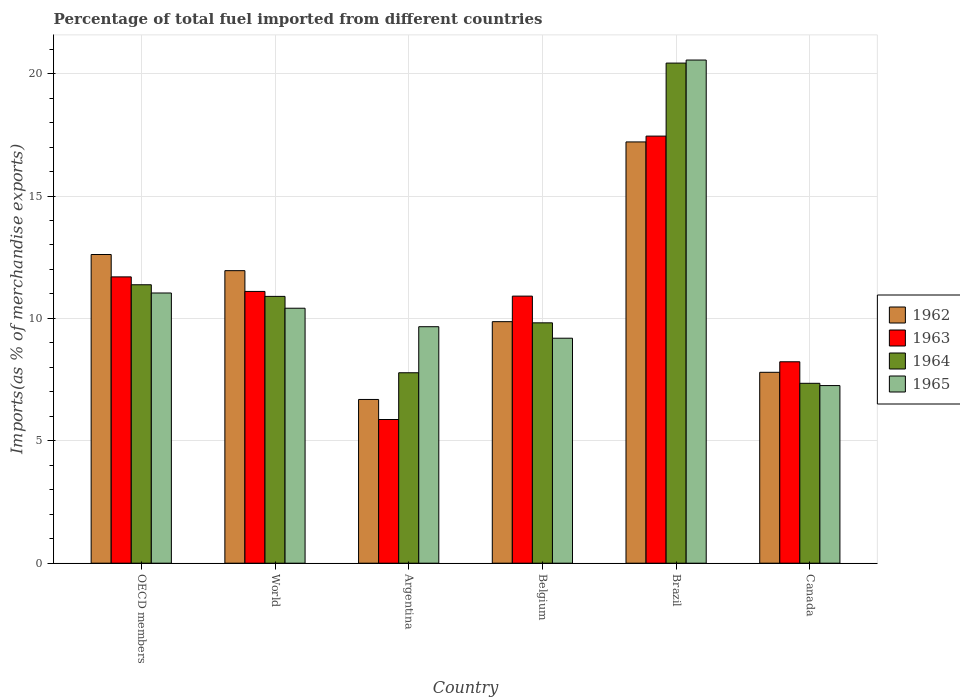How many different coloured bars are there?
Provide a short and direct response. 4. How many groups of bars are there?
Provide a succinct answer. 6. Are the number of bars on each tick of the X-axis equal?
Your response must be concise. Yes. How many bars are there on the 1st tick from the left?
Give a very brief answer. 4. What is the label of the 3rd group of bars from the left?
Keep it short and to the point. Argentina. In how many cases, is the number of bars for a given country not equal to the number of legend labels?
Provide a succinct answer. 0. What is the percentage of imports to different countries in 1962 in Argentina?
Provide a short and direct response. 6.69. Across all countries, what is the maximum percentage of imports to different countries in 1962?
Ensure brevity in your answer.  17.21. Across all countries, what is the minimum percentage of imports to different countries in 1965?
Your response must be concise. 7.26. In which country was the percentage of imports to different countries in 1964 maximum?
Keep it short and to the point. Brazil. What is the total percentage of imports to different countries in 1963 in the graph?
Your answer should be very brief. 65.25. What is the difference between the percentage of imports to different countries in 1963 in Argentina and that in Belgium?
Make the answer very short. -5.04. What is the difference between the percentage of imports to different countries in 1962 in Brazil and the percentage of imports to different countries in 1965 in Canada?
Provide a succinct answer. 9.95. What is the average percentage of imports to different countries in 1965 per country?
Provide a succinct answer. 11.35. What is the difference between the percentage of imports to different countries of/in 1965 and percentage of imports to different countries of/in 1962 in Argentina?
Keep it short and to the point. 2.97. What is the ratio of the percentage of imports to different countries in 1962 in Belgium to that in World?
Offer a terse response. 0.83. Is the percentage of imports to different countries in 1965 in Argentina less than that in World?
Keep it short and to the point. Yes. Is the difference between the percentage of imports to different countries in 1965 in Belgium and Canada greater than the difference between the percentage of imports to different countries in 1962 in Belgium and Canada?
Provide a succinct answer. No. What is the difference between the highest and the second highest percentage of imports to different countries in 1964?
Your answer should be very brief. -0.48. What is the difference between the highest and the lowest percentage of imports to different countries in 1965?
Offer a terse response. 13.3. Is the sum of the percentage of imports to different countries in 1965 in Belgium and Canada greater than the maximum percentage of imports to different countries in 1962 across all countries?
Your answer should be compact. No. Is it the case that in every country, the sum of the percentage of imports to different countries in 1965 and percentage of imports to different countries in 1963 is greater than the sum of percentage of imports to different countries in 1962 and percentage of imports to different countries in 1964?
Your answer should be very brief. No. What does the 3rd bar from the left in Canada represents?
Keep it short and to the point. 1964. What does the 3rd bar from the right in Brazil represents?
Keep it short and to the point. 1963. Is it the case that in every country, the sum of the percentage of imports to different countries in 1962 and percentage of imports to different countries in 1963 is greater than the percentage of imports to different countries in 1965?
Your answer should be compact. Yes. How many bars are there?
Keep it short and to the point. 24. How many countries are there in the graph?
Ensure brevity in your answer.  6. Does the graph contain any zero values?
Your answer should be very brief. No. Does the graph contain grids?
Provide a succinct answer. Yes. Where does the legend appear in the graph?
Provide a short and direct response. Center right. What is the title of the graph?
Give a very brief answer. Percentage of total fuel imported from different countries. Does "1965" appear as one of the legend labels in the graph?
Offer a very short reply. Yes. What is the label or title of the Y-axis?
Give a very brief answer. Imports(as % of merchandise exports). What is the Imports(as % of merchandise exports) in 1962 in OECD members?
Provide a succinct answer. 12.61. What is the Imports(as % of merchandise exports) in 1963 in OECD members?
Keep it short and to the point. 11.7. What is the Imports(as % of merchandise exports) in 1964 in OECD members?
Keep it short and to the point. 11.37. What is the Imports(as % of merchandise exports) of 1965 in OECD members?
Your answer should be very brief. 11.04. What is the Imports(as % of merchandise exports) in 1962 in World?
Offer a very short reply. 11.95. What is the Imports(as % of merchandise exports) in 1963 in World?
Give a very brief answer. 11.1. What is the Imports(as % of merchandise exports) of 1964 in World?
Your response must be concise. 10.9. What is the Imports(as % of merchandise exports) of 1965 in World?
Your response must be concise. 10.42. What is the Imports(as % of merchandise exports) in 1962 in Argentina?
Make the answer very short. 6.69. What is the Imports(as % of merchandise exports) of 1963 in Argentina?
Offer a terse response. 5.87. What is the Imports(as % of merchandise exports) of 1964 in Argentina?
Make the answer very short. 7.78. What is the Imports(as % of merchandise exports) of 1965 in Argentina?
Provide a short and direct response. 9.66. What is the Imports(as % of merchandise exports) in 1962 in Belgium?
Your answer should be very brief. 9.87. What is the Imports(as % of merchandise exports) of 1963 in Belgium?
Give a very brief answer. 10.91. What is the Imports(as % of merchandise exports) in 1964 in Belgium?
Keep it short and to the point. 9.82. What is the Imports(as % of merchandise exports) in 1965 in Belgium?
Ensure brevity in your answer.  9.19. What is the Imports(as % of merchandise exports) of 1962 in Brazil?
Make the answer very short. 17.21. What is the Imports(as % of merchandise exports) of 1963 in Brazil?
Keep it short and to the point. 17.45. What is the Imports(as % of merchandise exports) in 1964 in Brazil?
Make the answer very short. 20.43. What is the Imports(as % of merchandise exports) in 1965 in Brazil?
Provide a succinct answer. 20.55. What is the Imports(as % of merchandise exports) of 1962 in Canada?
Ensure brevity in your answer.  7.8. What is the Imports(as % of merchandise exports) in 1963 in Canada?
Provide a short and direct response. 8.23. What is the Imports(as % of merchandise exports) in 1964 in Canada?
Provide a succinct answer. 7.35. What is the Imports(as % of merchandise exports) in 1965 in Canada?
Ensure brevity in your answer.  7.26. Across all countries, what is the maximum Imports(as % of merchandise exports) in 1962?
Give a very brief answer. 17.21. Across all countries, what is the maximum Imports(as % of merchandise exports) in 1963?
Your response must be concise. 17.45. Across all countries, what is the maximum Imports(as % of merchandise exports) in 1964?
Provide a short and direct response. 20.43. Across all countries, what is the maximum Imports(as % of merchandise exports) of 1965?
Your response must be concise. 20.55. Across all countries, what is the minimum Imports(as % of merchandise exports) of 1962?
Your answer should be very brief. 6.69. Across all countries, what is the minimum Imports(as % of merchandise exports) of 1963?
Your answer should be very brief. 5.87. Across all countries, what is the minimum Imports(as % of merchandise exports) in 1964?
Keep it short and to the point. 7.35. Across all countries, what is the minimum Imports(as % of merchandise exports) of 1965?
Offer a terse response. 7.26. What is the total Imports(as % of merchandise exports) in 1962 in the graph?
Provide a short and direct response. 66.12. What is the total Imports(as % of merchandise exports) of 1963 in the graph?
Offer a terse response. 65.25. What is the total Imports(as % of merchandise exports) of 1964 in the graph?
Ensure brevity in your answer.  67.65. What is the total Imports(as % of merchandise exports) in 1965 in the graph?
Your answer should be compact. 68.12. What is the difference between the Imports(as % of merchandise exports) of 1962 in OECD members and that in World?
Offer a terse response. 0.66. What is the difference between the Imports(as % of merchandise exports) in 1963 in OECD members and that in World?
Offer a terse response. 0.59. What is the difference between the Imports(as % of merchandise exports) in 1964 in OECD members and that in World?
Make the answer very short. 0.48. What is the difference between the Imports(as % of merchandise exports) in 1965 in OECD members and that in World?
Keep it short and to the point. 0.62. What is the difference between the Imports(as % of merchandise exports) of 1962 in OECD members and that in Argentina?
Give a very brief answer. 5.92. What is the difference between the Imports(as % of merchandise exports) in 1963 in OECD members and that in Argentina?
Offer a very short reply. 5.83. What is the difference between the Imports(as % of merchandise exports) of 1964 in OECD members and that in Argentina?
Offer a terse response. 3.59. What is the difference between the Imports(as % of merchandise exports) of 1965 in OECD members and that in Argentina?
Give a very brief answer. 1.38. What is the difference between the Imports(as % of merchandise exports) of 1962 in OECD members and that in Belgium?
Provide a short and direct response. 2.74. What is the difference between the Imports(as % of merchandise exports) in 1963 in OECD members and that in Belgium?
Offer a terse response. 0.79. What is the difference between the Imports(as % of merchandise exports) in 1964 in OECD members and that in Belgium?
Give a very brief answer. 1.56. What is the difference between the Imports(as % of merchandise exports) in 1965 in OECD members and that in Belgium?
Your response must be concise. 1.85. What is the difference between the Imports(as % of merchandise exports) of 1962 in OECD members and that in Brazil?
Ensure brevity in your answer.  -4.6. What is the difference between the Imports(as % of merchandise exports) in 1963 in OECD members and that in Brazil?
Provide a succinct answer. -5.75. What is the difference between the Imports(as % of merchandise exports) in 1964 in OECD members and that in Brazil?
Offer a very short reply. -9.06. What is the difference between the Imports(as % of merchandise exports) in 1965 in OECD members and that in Brazil?
Your answer should be very brief. -9.52. What is the difference between the Imports(as % of merchandise exports) in 1962 in OECD members and that in Canada?
Give a very brief answer. 4.81. What is the difference between the Imports(as % of merchandise exports) of 1963 in OECD members and that in Canada?
Keep it short and to the point. 3.47. What is the difference between the Imports(as % of merchandise exports) of 1964 in OECD members and that in Canada?
Your response must be concise. 4.03. What is the difference between the Imports(as % of merchandise exports) in 1965 in OECD members and that in Canada?
Make the answer very short. 3.78. What is the difference between the Imports(as % of merchandise exports) of 1962 in World and that in Argentina?
Ensure brevity in your answer.  5.26. What is the difference between the Imports(as % of merchandise exports) of 1963 in World and that in Argentina?
Provide a short and direct response. 5.23. What is the difference between the Imports(as % of merchandise exports) in 1964 in World and that in Argentina?
Your answer should be compact. 3.12. What is the difference between the Imports(as % of merchandise exports) of 1965 in World and that in Argentina?
Provide a short and direct response. 0.76. What is the difference between the Imports(as % of merchandise exports) in 1962 in World and that in Belgium?
Make the answer very short. 2.08. What is the difference between the Imports(as % of merchandise exports) of 1963 in World and that in Belgium?
Offer a terse response. 0.19. What is the difference between the Imports(as % of merchandise exports) of 1964 in World and that in Belgium?
Keep it short and to the point. 1.08. What is the difference between the Imports(as % of merchandise exports) in 1965 in World and that in Belgium?
Provide a succinct answer. 1.23. What is the difference between the Imports(as % of merchandise exports) of 1962 in World and that in Brazil?
Make the answer very short. -5.26. What is the difference between the Imports(as % of merchandise exports) of 1963 in World and that in Brazil?
Give a very brief answer. -6.34. What is the difference between the Imports(as % of merchandise exports) in 1964 in World and that in Brazil?
Your answer should be very brief. -9.53. What is the difference between the Imports(as % of merchandise exports) in 1965 in World and that in Brazil?
Keep it short and to the point. -10.14. What is the difference between the Imports(as % of merchandise exports) in 1962 in World and that in Canada?
Your response must be concise. 4.15. What is the difference between the Imports(as % of merchandise exports) of 1963 in World and that in Canada?
Your answer should be compact. 2.87. What is the difference between the Imports(as % of merchandise exports) of 1964 in World and that in Canada?
Offer a very short reply. 3.55. What is the difference between the Imports(as % of merchandise exports) in 1965 in World and that in Canada?
Offer a terse response. 3.16. What is the difference between the Imports(as % of merchandise exports) in 1962 in Argentina and that in Belgium?
Give a very brief answer. -3.18. What is the difference between the Imports(as % of merchandise exports) in 1963 in Argentina and that in Belgium?
Your answer should be very brief. -5.04. What is the difference between the Imports(as % of merchandise exports) in 1964 in Argentina and that in Belgium?
Your response must be concise. -2.04. What is the difference between the Imports(as % of merchandise exports) in 1965 in Argentina and that in Belgium?
Your response must be concise. 0.47. What is the difference between the Imports(as % of merchandise exports) in 1962 in Argentina and that in Brazil?
Your answer should be compact. -10.52. What is the difference between the Imports(as % of merchandise exports) of 1963 in Argentina and that in Brazil?
Keep it short and to the point. -11.58. What is the difference between the Imports(as % of merchandise exports) in 1964 in Argentina and that in Brazil?
Your answer should be compact. -12.65. What is the difference between the Imports(as % of merchandise exports) in 1965 in Argentina and that in Brazil?
Provide a short and direct response. -10.89. What is the difference between the Imports(as % of merchandise exports) in 1962 in Argentina and that in Canada?
Provide a short and direct response. -1.11. What is the difference between the Imports(as % of merchandise exports) in 1963 in Argentina and that in Canada?
Make the answer very short. -2.36. What is the difference between the Imports(as % of merchandise exports) of 1964 in Argentina and that in Canada?
Provide a short and direct response. 0.43. What is the difference between the Imports(as % of merchandise exports) of 1965 in Argentina and that in Canada?
Give a very brief answer. 2.4. What is the difference between the Imports(as % of merchandise exports) in 1962 in Belgium and that in Brazil?
Provide a succinct answer. -7.34. What is the difference between the Imports(as % of merchandise exports) in 1963 in Belgium and that in Brazil?
Give a very brief answer. -6.54. What is the difference between the Imports(as % of merchandise exports) in 1964 in Belgium and that in Brazil?
Keep it short and to the point. -10.61. What is the difference between the Imports(as % of merchandise exports) of 1965 in Belgium and that in Brazil?
Give a very brief answer. -11.36. What is the difference between the Imports(as % of merchandise exports) of 1962 in Belgium and that in Canada?
Make the answer very short. 2.07. What is the difference between the Imports(as % of merchandise exports) of 1963 in Belgium and that in Canada?
Offer a terse response. 2.68. What is the difference between the Imports(as % of merchandise exports) in 1964 in Belgium and that in Canada?
Provide a short and direct response. 2.47. What is the difference between the Imports(as % of merchandise exports) in 1965 in Belgium and that in Canada?
Provide a succinct answer. 1.93. What is the difference between the Imports(as % of merchandise exports) of 1962 in Brazil and that in Canada?
Keep it short and to the point. 9.41. What is the difference between the Imports(as % of merchandise exports) in 1963 in Brazil and that in Canada?
Your answer should be compact. 9.22. What is the difference between the Imports(as % of merchandise exports) in 1964 in Brazil and that in Canada?
Your response must be concise. 13.08. What is the difference between the Imports(as % of merchandise exports) of 1965 in Brazil and that in Canada?
Provide a succinct answer. 13.3. What is the difference between the Imports(as % of merchandise exports) in 1962 in OECD members and the Imports(as % of merchandise exports) in 1963 in World?
Offer a terse response. 1.51. What is the difference between the Imports(as % of merchandise exports) in 1962 in OECD members and the Imports(as % of merchandise exports) in 1964 in World?
Ensure brevity in your answer.  1.71. What is the difference between the Imports(as % of merchandise exports) of 1962 in OECD members and the Imports(as % of merchandise exports) of 1965 in World?
Make the answer very short. 2.19. What is the difference between the Imports(as % of merchandise exports) of 1963 in OECD members and the Imports(as % of merchandise exports) of 1964 in World?
Make the answer very short. 0.8. What is the difference between the Imports(as % of merchandise exports) of 1963 in OECD members and the Imports(as % of merchandise exports) of 1965 in World?
Your response must be concise. 1.28. What is the difference between the Imports(as % of merchandise exports) of 1964 in OECD members and the Imports(as % of merchandise exports) of 1965 in World?
Offer a very short reply. 0.96. What is the difference between the Imports(as % of merchandise exports) of 1962 in OECD members and the Imports(as % of merchandise exports) of 1963 in Argentina?
Offer a very short reply. 6.74. What is the difference between the Imports(as % of merchandise exports) of 1962 in OECD members and the Imports(as % of merchandise exports) of 1964 in Argentina?
Your answer should be compact. 4.83. What is the difference between the Imports(as % of merchandise exports) in 1962 in OECD members and the Imports(as % of merchandise exports) in 1965 in Argentina?
Your response must be concise. 2.95. What is the difference between the Imports(as % of merchandise exports) in 1963 in OECD members and the Imports(as % of merchandise exports) in 1964 in Argentina?
Offer a terse response. 3.92. What is the difference between the Imports(as % of merchandise exports) of 1963 in OECD members and the Imports(as % of merchandise exports) of 1965 in Argentina?
Provide a succinct answer. 2.04. What is the difference between the Imports(as % of merchandise exports) of 1964 in OECD members and the Imports(as % of merchandise exports) of 1965 in Argentina?
Your response must be concise. 1.71. What is the difference between the Imports(as % of merchandise exports) in 1962 in OECD members and the Imports(as % of merchandise exports) in 1963 in Belgium?
Ensure brevity in your answer.  1.7. What is the difference between the Imports(as % of merchandise exports) in 1962 in OECD members and the Imports(as % of merchandise exports) in 1964 in Belgium?
Offer a very short reply. 2.79. What is the difference between the Imports(as % of merchandise exports) in 1962 in OECD members and the Imports(as % of merchandise exports) in 1965 in Belgium?
Provide a short and direct response. 3.42. What is the difference between the Imports(as % of merchandise exports) in 1963 in OECD members and the Imports(as % of merchandise exports) in 1964 in Belgium?
Make the answer very short. 1.88. What is the difference between the Imports(as % of merchandise exports) in 1963 in OECD members and the Imports(as % of merchandise exports) in 1965 in Belgium?
Provide a succinct answer. 2.51. What is the difference between the Imports(as % of merchandise exports) of 1964 in OECD members and the Imports(as % of merchandise exports) of 1965 in Belgium?
Offer a terse response. 2.18. What is the difference between the Imports(as % of merchandise exports) of 1962 in OECD members and the Imports(as % of merchandise exports) of 1963 in Brazil?
Your answer should be very brief. -4.84. What is the difference between the Imports(as % of merchandise exports) in 1962 in OECD members and the Imports(as % of merchandise exports) in 1964 in Brazil?
Keep it short and to the point. -7.82. What is the difference between the Imports(as % of merchandise exports) of 1962 in OECD members and the Imports(as % of merchandise exports) of 1965 in Brazil?
Your response must be concise. -7.94. What is the difference between the Imports(as % of merchandise exports) in 1963 in OECD members and the Imports(as % of merchandise exports) in 1964 in Brazil?
Ensure brevity in your answer.  -8.73. What is the difference between the Imports(as % of merchandise exports) of 1963 in OECD members and the Imports(as % of merchandise exports) of 1965 in Brazil?
Your answer should be compact. -8.86. What is the difference between the Imports(as % of merchandise exports) in 1964 in OECD members and the Imports(as % of merchandise exports) in 1965 in Brazil?
Provide a succinct answer. -9.18. What is the difference between the Imports(as % of merchandise exports) in 1962 in OECD members and the Imports(as % of merchandise exports) in 1963 in Canada?
Provide a succinct answer. 4.38. What is the difference between the Imports(as % of merchandise exports) in 1962 in OECD members and the Imports(as % of merchandise exports) in 1964 in Canada?
Provide a short and direct response. 5.26. What is the difference between the Imports(as % of merchandise exports) in 1962 in OECD members and the Imports(as % of merchandise exports) in 1965 in Canada?
Provide a succinct answer. 5.35. What is the difference between the Imports(as % of merchandise exports) in 1963 in OECD members and the Imports(as % of merchandise exports) in 1964 in Canada?
Offer a very short reply. 4.35. What is the difference between the Imports(as % of merchandise exports) of 1963 in OECD members and the Imports(as % of merchandise exports) of 1965 in Canada?
Your answer should be compact. 4.44. What is the difference between the Imports(as % of merchandise exports) in 1964 in OECD members and the Imports(as % of merchandise exports) in 1965 in Canada?
Your answer should be compact. 4.12. What is the difference between the Imports(as % of merchandise exports) in 1962 in World and the Imports(as % of merchandise exports) in 1963 in Argentina?
Your answer should be very brief. 6.08. What is the difference between the Imports(as % of merchandise exports) of 1962 in World and the Imports(as % of merchandise exports) of 1964 in Argentina?
Give a very brief answer. 4.17. What is the difference between the Imports(as % of merchandise exports) in 1962 in World and the Imports(as % of merchandise exports) in 1965 in Argentina?
Keep it short and to the point. 2.29. What is the difference between the Imports(as % of merchandise exports) in 1963 in World and the Imports(as % of merchandise exports) in 1964 in Argentina?
Offer a terse response. 3.32. What is the difference between the Imports(as % of merchandise exports) of 1963 in World and the Imports(as % of merchandise exports) of 1965 in Argentina?
Keep it short and to the point. 1.44. What is the difference between the Imports(as % of merchandise exports) of 1964 in World and the Imports(as % of merchandise exports) of 1965 in Argentina?
Ensure brevity in your answer.  1.24. What is the difference between the Imports(as % of merchandise exports) of 1962 in World and the Imports(as % of merchandise exports) of 1963 in Belgium?
Provide a short and direct response. 1.04. What is the difference between the Imports(as % of merchandise exports) in 1962 in World and the Imports(as % of merchandise exports) in 1964 in Belgium?
Your response must be concise. 2.13. What is the difference between the Imports(as % of merchandise exports) in 1962 in World and the Imports(as % of merchandise exports) in 1965 in Belgium?
Ensure brevity in your answer.  2.76. What is the difference between the Imports(as % of merchandise exports) in 1963 in World and the Imports(as % of merchandise exports) in 1964 in Belgium?
Your answer should be compact. 1.28. What is the difference between the Imports(as % of merchandise exports) of 1963 in World and the Imports(as % of merchandise exports) of 1965 in Belgium?
Your answer should be compact. 1.91. What is the difference between the Imports(as % of merchandise exports) in 1964 in World and the Imports(as % of merchandise exports) in 1965 in Belgium?
Give a very brief answer. 1.71. What is the difference between the Imports(as % of merchandise exports) in 1962 in World and the Imports(as % of merchandise exports) in 1963 in Brazil?
Offer a terse response. -5.5. What is the difference between the Imports(as % of merchandise exports) in 1962 in World and the Imports(as % of merchandise exports) in 1964 in Brazil?
Offer a terse response. -8.48. What is the difference between the Imports(as % of merchandise exports) of 1962 in World and the Imports(as % of merchandise exports) of 1965 in Brazil?
Your answer should be very brief. -8.6. What is the difference between the Imports(as % of merchandise exports) of 1963 in World and the Imports(as % of merchandise exports) of 1964 in Brazil?
Offer a terse response. -9.33. What is the difference between the Imports(as % of merchandise exports) in 1963 in World and the Imports(as % of merchandise exports) in 1965 in Brazil?
Offer a terse response. -9.45. What is the difference between the Imports(as % of merchandise exports) in 1964 in World and the Imports(as % of merchandise exports) in 1965 in Brazil?
Keep it short and to the point. -9.66. What is the difference between the Imports(as % of merchandise exports) in 1962 in World and the Imports(as % of merchandise exports) in 1963 in Canada?
Give a very brief answer. 3.72. What is the difference between the Imports(as % of merchandise exports) of 1962 in World and the Imports(as % of merchandise exports) of 1964 in Canada?
Your response must be concise. 4.6. What is the difference between the Imports(as % of merchandise exports) of 1962 in World and the Imports(as % of merchandise exports) of 1965 in Canada?
Provide a short and direct response. 4.69. What is the difference between the Imports(as % of merchandise exports) in 1963 in World and the Imports(as % of merchandise exports) in 1964 in Canada?
Your answer should be very brief. 3.75. What is the difference between the Imports(as % of merchandise exports) in 1963 in World and the Imports(as % of merchandise exports) in 1965 in Canada?
Your answer should be very brief. 3.85. What is the difference between the Imports(as % of merchandise exports) in 1964 in World and the Imports(as % of merchandise exports) in 1965 in Canada?
Give a very brief answer. 3.64. What is the difference between the Imports(as % of merchandise exports) of 1962 in Argentina and the Imports(as % of merchandise exports) of 1963 in Belgium?
Your answer should be very brief. -4.22. What is the difference between the Imports(as % of merchandise exports) of 1962 in Argentina and the Imports(as % of merchandise exports) of 1964 in Belgium?
Your response must be concise. -3.13. What is the difference between the Imports(as % of merchandise exports) in 1962 in Argentina and the Imports(as % of merchandise exports) in 1965 in Belgium?
Offer a very short reply. -2.5. What is the difference between the Imports(as % of merchandise exports) of 1963 in Argentina and the Imports(as % of merchandise exports) of 1964 in Belgium?
Provide a short and direct response. -3.95. What is the difference between the Imports(as % of merchandise exports) in 1963 in Argentina and the Imports(as % of merchandise exports) in 1965 in Belgium?
Your answer should be very brief. -3.32. What is the difference between the Imports(as % of merchandise exports) in 1964 in Argentina and the Imports(as % of merchandise exports) in 1965 in Belgium?
Offer a terse response. -1.41. What is the difference between the Imports(as % of merchandise exports) in 1962 in Argentina and the Imports(as % of merchandise exports) in 1963 in Brazil?
Offer a very short reply. -10.76. What is the difference between the Imports(as % of merchandise exports) of 1962 in Argentina and the Imports(as % of merchandise exports) of 1964 in Brazil?
Your response must be concise. -13.74. What is the difference between the Imports(as % of merchandise exports) in 1962 in Argentina and the Imports(as % of merchandise exports) in 1965 in Brazil?
Give a very brief answer. -13.87. What is the difference between the Imports(as % of merchandise exports) in 1963 in Argentina and the Imports(as % of merchandise exports) in 1964 in Brazil?
Offer a terse response. -14.56. What is the difference between the Imports(as % of merchandise exports) of 1963 in Argentina and the Imports(as % of merchandise exports) of 1965 in Brazil?
Offer a very short reply. -14.68. What is the difference between the Imports(as % of merchandise exports) of 1964 in Argentina and the Imports(as % of merchandise exports) of 1965 in Brazil?
Your answer should be compact. -12.77. What is the difference between the Imports(as % of merchandise exports) in 1962 in Argentina and the Imports(as % of merchandise exports) in 1963 in Canada?
Ensure brevity in your answer.  -1.54. What is the difference between the Imports(as % of merchandise exports) in 1962 in Argentina and the Imports(as % of merchandise exports) in 1964 in Canada?
Ensure brevity in your answer.  -0.66. What is the difference between the Imports(as % of merchandise exports) in 1962 in Argentina and the Imports(as % of merchandise exports) in 1965 in Canada?
Offer a very short reply. -0.57. What is the difference between the Imports(as % of merchandise exports) of 1963 in Argentina and the Imports(as % of merchandise exports) of 1964 in Canada?
Offer a very short reply. -1.48. What is the difference between the Imports(as % of merchandise exports) in 1963 in Argentina and the Imports(as % of merchandise exports) in 1965 in Canada?
Provide a succinct answer. -1.39. What is the difference between the Imports(as % of merchandise exports) of 1964 in Argentina and the Imports(as % of merchandise exports) of 1965 in Canada?
Make the answer very short. 0.52. What is the difference between the Imports(as % of merchandise exports) of 1962 in Belgium and the Imports(as % of merchandise exports) of 1963 in Brazil?
Your answer should be compact. -7.58. What is the difference between the Imports(as % of merchandise exports) of 1962 in Belgium and the Imports(as % of merchandise exports) of 1964 in Brazil?
Offer a very short reply. -10.56. What is the difference between the Imports(as % of merchandise exports) of 1962 in Belgium and the Imports(as % of merchandise exports) of 1965 in Brazil?
Provide a succinct answer. -10.69. What is the difference between the Imports(as % of merchandise exports) of 1963 in Belgium and the Imports(as % of merchandise exports) of 1964 in Brazil?
Give a very brief answer. -9.52. What is the difference between the Imports(as % of merchandise exports) in 1963 in Belgium and the Imports(as % of merchandise exports) in 1965 in Brazil?
Provide a succinct answer. -9.64. What is the difference between the Imports(as % of merchandise exports) of 1964 in Belgium and the Imports(as % of merchandise exports) of 1965 in Brazil?
Offer a terse response. -10.74. What is the difference between the Imports(as % of merchandise exports) of 1962 in Belgium and the Imports(as % of merchandise exports) of 1963 in Canada?
Your answer should be very brief. 1.64. What is the difference between the Imports(as % of merchandise exports) in 1962 in Belgium and the Imports(as % of merchandise exports) in 1964 in Canada?
Make the answer very short. 2.52. What is the difference between the Imports(as % of merchandise exports) in 1962 in Belgium and the Imports(as % of merchandise exports) in 1965 in Canada?
Provide a short and direct response. 2.61. What is the difference between the Imports(as % of merchandise exports) of 1963 in Belgium and the Imports(as % of merchandise exports) of 1964 in Canada?
Provide a succinct answer. 3.56. What is the difference between the Imports(as % of merchandise exports) of 1963 in Belgium and the Imports(as % of merchandise exports) of 1965 in Canada?
Keep it short and to the point. 3.65. What is the difference between the Imports(as % of merchandise exports) in 1964 in Belgium and the Imports(as % of merchandise exports) in 1965 in Canada?
Your answer should be compact. 2.56. What is the difference between the Imports(as % of merchandise exports) in 1962 in Brazil and the Imports(as % of merchandise exports) in 1963 in Canada?
Make the answer very short. 8.98. What is the difference between the Imports(as % of merchandise exports) in 1962 in Brazil and the Imports(as % of merchandise exports) in 1964 in Canada?
Offer a terse response. 9.86. What is the difference between the Imports(as % of merchandise exports) in 1962 in Brazil and the Imports(as % of merchandise exports) in 1965 in Canada?
Your answer should be compact. 9.95. What is the difference between the Imports(as % of merchandise exports) of 1963 in Brazil and the Imports(as % of merchandise exports) of 1964 in Canada?
Ensure brevity in your answer.  10.1. What is the difference between the Imports(as % of merchandise exports) of 1963 in Brazil and the Imports(as % of merchandise exports) of 1965 in Canada?
Your answer should be very brief. 10.19. What is the difference between the Imports(as % of merchandise exports) of 1964 in Brazil and the Imports(as % of merchandise exports) of 1965 in Canada?
Offer a terse response. 13.17. What is the average Imports(as % of merchandise exports) in 1962 per country?
Offer a terse response. 11.02. What is the average Imports(as % of merchandise exports) of 1963 per country?
Your response must be concise. 10.88. What is the average Imports(as % of merchandise exports) in 1964 per country?
Provide a succinct answer. 11.28. What is the average Imports(as % of merchandise exports) in 1965 per country?
Ensure brevity in your answer.  11.35. What is the difference between the Imports(as % of merchandise exports) in 1962 and Imports(as % of merchandise exports) in 1963 in OECD members?
Your answer should be very brief. 0.91. What is the difference between the Imports(as % of merchandise exports) in 1962 and Imports(as % of merchandise exports) in 1964 in OECD members?
Your response must be concise. 1.24. What is the difference between the Imports(as % of merchandise exports) in 1962 and Imports(as % of merchandise exports) in 1965 in OECD members?
Keep it short and to the point. 1.57. What is the difference between the Imports(as % of merchandise exports) of 1963 and Imports(as % of merchandise exports) of 1964 in OECD members?
Keep it short and to the point. 0.32. What is the difference between the Imports(as % of merchandise exports) of 1963 and Imports(as % of merchandise exports) of 1965 in OECD members?
Your answer should be compact. 0.66. What is the difference between the Imports(as % of merchandise exports) of 1964 and Imports(as % of merchandise exports) of 1965 in OECD members?
Offer a very short reply. 0.34. What is the difference between the Imports(as % of merchandise exports) of 1962 and Imports(as % of merchandise exports) of 1963 in World?
Your answer should be compact. 0.85. What is the difference between the Imports(as % of merchandise exports) in 1962 and Imports(as % of merchandise exports) in 1964 in World?
Provide a succinct answer. 1.05. What is the difference between the Imports(as % of merchandise exports) of 1962 and Imports(as % of merchandise exports) of 1965 in World?
Your response must be concise. 1.53. What is the difference between the Imports(as % of merchandise exports) of 1963 and Imports(as % of merchandise exports) of 1964 in World?
Your answer should be compact. 0.2. What is the difference between the Imports(as % of merchandise exports) of 1963 and Imports(as % of merchandise exports) of 1965 in World?
Your response must be concise. 0.69. What is the difference between the Imports(as % of merchandise exports) of 1964 and Imports(as % of merchandise exports) of 1965 in World?
Give a very brief answer. 0.48. What is the difference between the Imports(as % of merchandise exports) in 1962 and Imports(as % of merchandise exports) in 1963 in Argentina?
Offer a very short reply. 0.82. What is the difference between the Imports(as % of merchandise exports) of 1962 and Imports(as % of merchandise exports) of 1964 in Argentina?
Offer a terse response. -1.09. What is the difference between the Imports(as % of merchandise exports) in 1962 and Imports(as % of merchandise exports) in 1965 in Argentina?
Your response must be concise. -2.97. What is the difference between the Imports(as % of merchandise exports) in 1963 and Imports(as % of merchandise exports) in 1964 in Argentina?
Offer a terse response. -1.91. What is the difference between the Imports(as % of merchandise exports) of 1963 and Imports(as % of merchandise exports) of 1965 in Argentina?
Your answer should be compact. -3.79. What is the difference between the Imports(as % of merchandise exports) of 1964 and Imports(as % of merchandise exports) of 1965 in Argentina?
Make the answer very short. -1.88. What is the difference between the Imports(as % of merchandise exports) in 1962 and Imports(as % of merchandise exports) in 1963 in Belgium?
Make the answer very short. -1.04. What is the difference between the Imports(as % of merchandise exports) of 1962 and Imports(as % of merchandise exports) of 1964 in Belgium?
Your response must be concise. 0.05. What is the difference between the Imports(as % of merchandise exports) of 1962 and Imports(as % of merchandise exports) of 1965 in Belgium?
Provide a succinct answer. 0.68. What is the difference between the Imports(as % of merchandise exports) in 1963 and Imports(as % of merchandise exports) in 1964 in Belgium?
Provide a succinct answer. 1.09. What is the difference between the Imports(as % of merchandise exports) of 1963 and Imports(as % of merchandise exports) of 1965 in Belgium?
Ensure brevity in your answer.  1.72. What is the difference between the Imports(as % of merchandise exports) of 1964 and Imports(as % of merchandise exports) of 1965 in Belgium?
Make the answer very short. 0.63. What is the difference between the Imports(as % of merchandise exports) of 1962 and Imports(as % of merchandise exports) of 1963 in Brazil?
Ensure brevity in your answer.  -0.24. What is the difference between the Imports(as % of merchandise exports) in 1962 and Imports(as % of merchandise exports) in 1964 in Brazil?
Make the answer very short. -3.22. What is the difference between the Imports(as % of merchandise exports) of 1962 and Imports(as % of merchandise exports) of 1965 in Brazil?
Make the answer very short. -3.35. What is the difference between the Imports(as % of merchandise exports) of 1963 and Imports(as % of merchandise exports) of 1964 in Brazil?
Provide a short and direct response. -2.98. What is the difference between the Imports(as % of merchandise exports) of 1963 and Imports(as % of merchandise exports) of 1965 in Brazil?
Make the answer very short. -3.11. What is the difference between the Imports(as % of merchandise exports) in 1964 and Imports(as % of merchandise exports) in 1965 in Brazil?
Your answer should be very brief. -0.12. What is the difference between the Imports(as % of merchandise exports) of 1962 and Imports(as % of merchandise exports) of 1963 in Canada?
Ensure brevity in your answer.  -0.43. What is the difference between the Imports(as % of merchandise exports) in 1962 and Imports(as % of merchandise exports) in 1964 in Canada?
Keep it short and to the point. 0.45. What is the difference between the Imports(as % of merchandise exports) of 1962 and Imports(as % of merchandise exports) of 1965 in Canada?
Keep it short and to the point. 0.54. What is the difference between the Imports(as % of merchandise exports) of 1963 and Imports(as % of merchandise exports) of 1964 in Canada?
Provide a short and direct response. 0.88. What is the difference between the Imports(as % of merchandise exports) in 1963 and Imports(as % of merchandise exports) in 1965 in Canada?
Offer a terse response. 0.97. What is the difference between the Imports(as % of merchandise exports) of 1964 and Imports(as % of merchandise exports) of 1965 in Canada?
Your response must be concise. 0.09. What is the ratio of the Imports(as % of merchandise exports) in 1962 in OECD members to that in World?
Offer a very short reply. 1.06. What is the ratio of the Imports(as % of merchandise exports) in 1963 in OECD members to that in World?
Offer a very short reply. 1.05. What is the ratio of the Imports(as % of merchandise exports) in 1964 in OECD members to that in World?
Provide a short and direct response. 1.04. What is the ratio of the Imports(as % of merchandise exports) in 1965 in OECD members to that in World?
Give a very brief answer. 1.06. What is the ratio of the Imports(as % of merchandise exports) of 1962 in OECD members to that in Argentina?
Your answer should be compact. 1.89. What is the ratio of the Imports(as % of merchandise exports) in 1963 in OECD members to that in Argentina?
Your answer should be very brief. 1.99. What is the ratio of the Imports(as % of merchandise exports) in 1964 in OECD members to that in Argentina?
Your answer should be compact. 1.46. What is the ratio of the Imports(as % of merchandise exports) of 1965 in OECD members to that in Argentina?
Provide a short and direct response. 1.14. What is the ratio of the Imports(as % of merchandise exports) of 1962 in OECD members to that in Belgium?
Keep it short and to the point. 1.28. What is the ratio of the Imports(as % of merchandise exports) of 1963 in OECD members to that in Belgium?
Keep it short and to the point. 1.07. What is the ratio of the Imports(as % of merchandise exports) in 1964 in OECD members to that in Belgium?
Your answer should be very brief. 1.16. What is the ratio of the Imports(as % of merchandise exports) in 1965 in OECD members to that in Belgium?
Your answer should be compact. 1.2. What is the ratio of the Imports(as % of merchandise exports) of 1962 in OECD members to that in Brazil?
Provide a succinct answer. 0.73. What is the ratio of the Imports(as % of merchandise exports) of 1963 in OECD members to that in Brazil?
Give a very brief answer. 0.67. What is the ratio of the Imports(as % of merchandise exports) in 1964 in OECD members to that in Brazil?
Your answer should be compact. 0.56. What is the ratio of the Imports(as % of merchandise exports) in 1965 in OECD members to that in Brazil?
Your response must be concise. 0.54. What is the ratio of the Imports(as % of merchandise exports) of 1962 in OECD members to that in Canada?
Your answer should be compact. 1.62. What is the ratio of the Imports(as % of merchandise exports) in 1963 in OECD members to that in Canada?
Keep it short and to the point. 1.42. What is the ratio of the Imports(as % of merchandise exports) of 1964 in OECD members to that in Canada?
Keep it short and to the point. 1.55. What is the ratio of the Imports(as % of merchandise exports) of 1965 in OECD members to that in Canada?
Keep it short and to the point. 1.52. What is the ratio of the Imports(as % of merchandise exports) in 1962 in World to that in Argentina?
Make the answer very short. 1.79. What is the ratio of the Imports(as % of merchandise exports) of 1963 in World to that in Argentina?
Your response must be concise. 1.89. What is the ratio of the Imports(as % of merchandise exports) in 1964 in World to that in Argentina?
Make the answer very short. 1.4. What is the ratio of the Imports(as % of merchandise exports) of 1965 in World to that in Argentina?
Your response must be concise. 1.08. What is the ratio of the Imports(as % of merchandise exports) of 1962 in World to that in Belgium?
Your answer should be very brief. 1.21. What is the ratio of the Imports(as % of merchandise exports) of 1963 in World to that in Belgium?
Ensure brevity in your answer.  1.02. What is the ratio of the Imports(as % of merchandise exports) in 1964 in World to that in Belgium?
Make the answer very short. 1.11. What is the ratio of the Imports(as % of merchandise exports) of 1965 in World to that in Belgium?
Offer a very short reply. 1.13. What is the ratio of the Imports(as % of merchandise exports) of 1962 in World to that in Brazil?
Give a very brief answer. 0.69. What is the ratio of the Imports(as % of merchandise exports) of 1963 in World to that in Brazil?
Provide a short and direct response. 0.64. What is the ratio of the Imports(as % of merchandise exports) of 1964 in World to that in Brazil?
Ensure brevity in your answer.  0.53. What is the ratio of the Imports(as % of merchandise exports) in 1965 in World to that in Brazil?
Your response must be concise. 0.51. What is the ratio of the Imports(as % of merchandise exports) in 1962 in World to that in Canada?
Provide a succinct answer. 1.53. What is the ratio of the Imports(as % of merchandise exports) in 1963 in World to that in Canada?
Your answer should be compact. 1.35. What is the ratio of the Imports(as % of merchandise exports) of 1964 in World to that in Canada?
Provide a succinct answer. 1.48. What is the ratio of the Imports(as % of merchandise exports) in 1965 in World to that in Canada?
Offer a terse response. 1.44. What is the ratio of the Imports(as % of merchandise exports) in 1962 in Argentina to that in Belgium?
Ensure brevity in your answer.  0.68. What is the ratio of the Imports(as % of merchandise exports) in 1963 in Argentina to that in Belgium?
Your answer should be very brief. 0.54. What is the ratio of the Imports(as % of merchandise exports) of 1964 in Argentina to that in Belgium?
Offer a very short reply. 0.79. What is the ratio of the Imports(as % of merchandise exports) in 1965 in Argentina to that in Belgium?
Make the answer very short. 1.05. What is the ratio of the Imports(as % of merchandise exports) of 1962 in Argentina to that in Brazil?
Your answer should be compact. 0.39. What is the ratio of the Imports(as % of merchandise exports) in 1963 in Argentina to that in Brazil?
Your answer should be very brief. 0.34. What is the ratio of the Imports(as % of merchandise exports) in 1964 in Argentina to that in Brazil?
Offer a very short reply. 0.38. What is the ratio of the Imports(as % of merchandise exports) in 1965 in Argentina to that in Brazil?
Provide a succinct answer. 0.47. What is the ratio of the Imports(as % of merchandise exports) of 1962 in Argentina to that in Canada?
Provide a succinct answer. 0.86. What is the ratio of the Imports(as % of merchandise exports) of 1963 in Argentina to that in Canada?
Ensure brevity in your answer.  0.71. What is the ratio of the Imports(as % of merchandise exports) in 1964 in Argentina to that in Canada?
Give a very brief answer. 1.06. What is the ratio of the Imports(as % of merchandise exports) in 1965 in Argentina to that in Canada?
Provide a short and direct response. 1.33. What is the ratio of the Imports(as % of merchandise exports) in 1962 in Belgium to that in Brazil?
Your response must be concise. 0.57. What is the ratio of the Imports(as % of merchandise exports) in 1963 in Belgium to that in Brazil?
Ensure brevity in your answer.  0.63. What is the ratio of the Imports(as % of merchandise exports) in 1964 in Belgium to that in Brazil?
Keep it short and to the point. 0.48. What is the ratio of the Imports(as % of merchandise exports) of 1965 in Belgium to that in Brazil?
Make the answer very short. 0.45. What is the ratio of the Imports(as % of merchandise exports) in 1962 in Belgium to that in Canada?
Offer a very short reply. 1.27. What is the ratio of the Imports(as % of merchandise exports) of 1963 in Belgium to that in Canada?
Offer a very short reply. 1.33. What is the ratio of the Imports(as % of merchandise exports) of 1964 in Belgium to that in Canada?
Your response must be concise. 1.34. What is the ratio of the Imports(as % of merchandise exports) in 1965 in Belgium to that in Canada?
Make the answer very short. 1.27. What is the ratio of the Imports(as % of merchandise exports) of 1962 in Brazil to that in Canada?
Ensure brevity in your answer.  2.21. What is the ratio of the Imports(as % of merchandise exports) in 1963 in Brazil to that in Canada?
Your response must be concise. 2.12. What is the ratio of the Imports(as % of merchandise exports) of 1964 in Brazil to that in Canada?
Your response must be concise. 2.78. What is the ratio of the Imports(as % of merchandise exports) of 1965 in Brazil to that in Canada?
Your response must be concise. 2.83. What is the difference between the highest and the second highest Imports(as % of merchandise exports) of 1962?
Offer a terse response. 4.6. What is the difference between the highest and the second highest Imports(as % of merchandise exports) in 1963?
Provide a succinct answer. 5.75. What is the difference between the highest and the second highest Imports(as % of merchandise exports) in 1964?
Provide a short and direct response. 9.06. What is the difference between the highest and the second highest Imports(as % of merchandise exports) of 1965?
Ensure brevity in your answer.  9.52. What is the difference between the highest and the lowest Imports(as % of merchandise exports) of 1962?
Provide a short and direct response. 10.52. What is the difference between the highest and the lowest Imports(as % of merchandise exports) of 1963?
Ensure brevity in your answer.  11.58. What is the difference between the highest and the lowest Imports(as % of merchandise exports) in 1964?
Your answer should be compact. 13.08. What is the difference between the highest and the lowest Imports(as % of merchandise exports) in 1965?
Give a very brief answer. 13.3. 